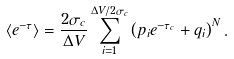<formula> <loc_0><loc_0><loc_500><loc_500>\langle e ^ { - \tau } \rangle = \frac { 2 \sigma _ { c } } { \Delta V } \sum _ { i = 1 } ^ { \Delta V / 2 \sigma _ { c } } \left ( p _ { i } e ^ { - \tau _ { c } } + q _ { i } \right ) ^ { N } .</formula> 